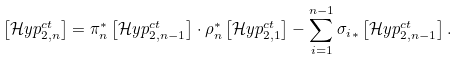<formula> <loc_0><loc_0><loc_500><loc_500>\left [ \mathcal { H } y p ^ { c t } _ { 2 , n } \right ] = \pi _ { n } ^ { * } \left [ \mathcal { H } y p ^ { c t } _ { 2 , n - 1 } \right ] \cdot \rho _ { n } ^ { * } \left [ \mathcal { H } y p ^ { c t } _ { 2 , 1 } \right ] - \sum _ { i = 1 } ^ { n - 1 } { \sigma _ { i } } _ { \ast } \left [ \mathcal { H } y p ^ { c t } _ { 2 , n - 1 } \right ] .</formula> 